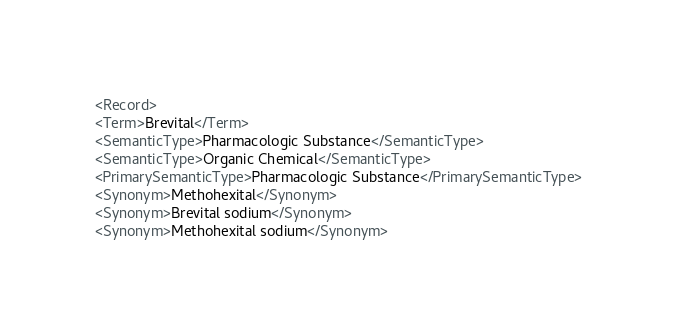Convert code to text. <code><loc_0><loc_0><loc_500><loc_500><_XML_><Record>
<Term>Brevital</Term>
<SemanticType>Pharmacologic Substance</SemanticType>
<SemanticType>Organic Chemical</SemanticType>
<PrimarySemanticType>Pharmacologic Substance</PrimarySemanticType>
<Synonym>Methohexital</Synonym>
<Synonym>Brevital sodium</Synonym>
<Synonym>Methohexital sodium</Synonym></code> 